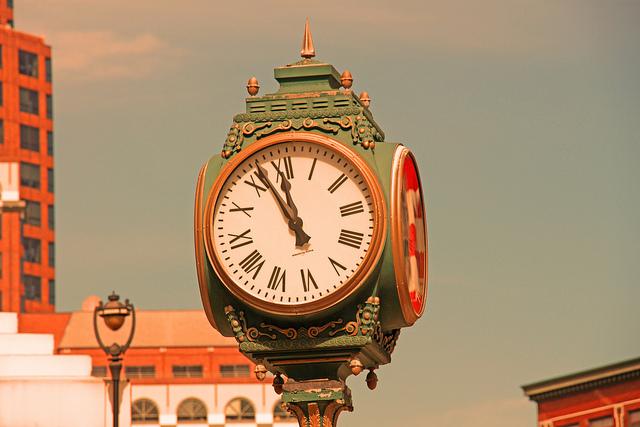What time is it?
Concise answer only. 11:56. What type of numerals are used on the clock?
Concise answer only. Roman. What time does the clock say?
Quick response, please. 11:56. What color is the top of the clock?
Write a very short answer. Green. 